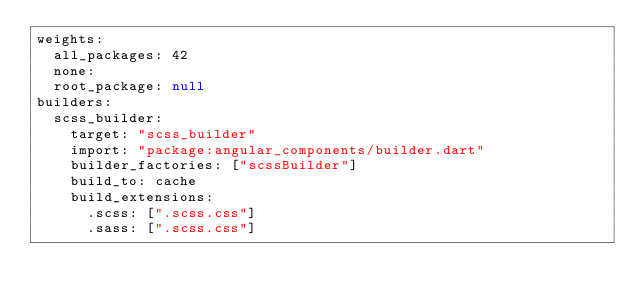Convert code to text. <code><loc_0><loc_0><loc_500><loc_500><_YAML_>weights:
  all_packages: 42
  none:
  root_package: null
builders:
  scss_builder:
    target: "scss_builder"
    import: "package:angular_components/builder.dart"
    builder_factories: ["scssBuilder"]
    build_to: cache
    build_extensions:
      .scss: [".scss.css"]
      .sass: [".scss.css"]
</code> 